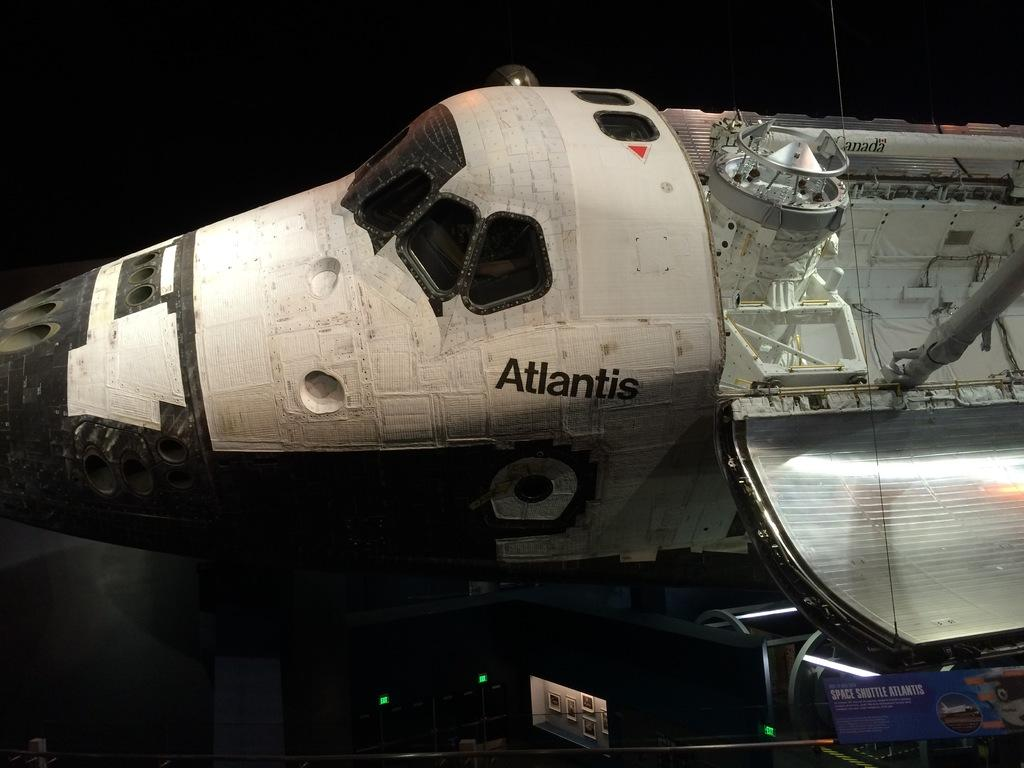<image>
Relay a brief, clear account of the picture shown. A old space shuttle with the word Atlantis on it. 